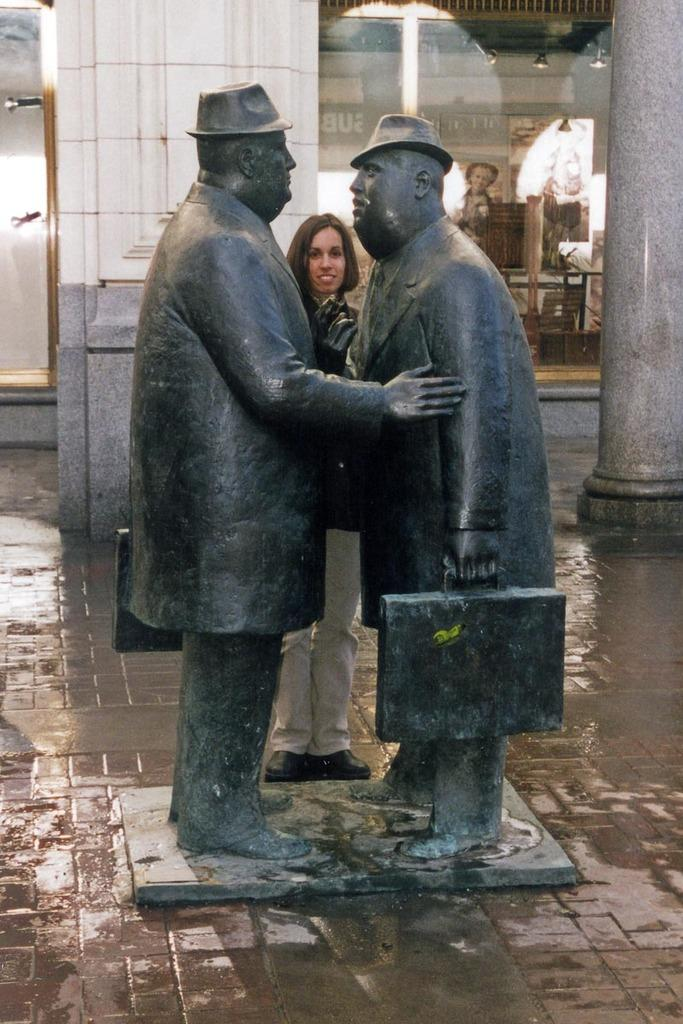How many statues are present in the image? There are two statues in the image. What is located behind the statues? There is a woman behind the statues. What can be seen in the background of the image? There are two pillars in the background of the image. What type of establishment is visible behind the pillars? There is a store behind the pillars. What type of fuel is being used by the bone in the image? There is no bone or fuel present in the image. 